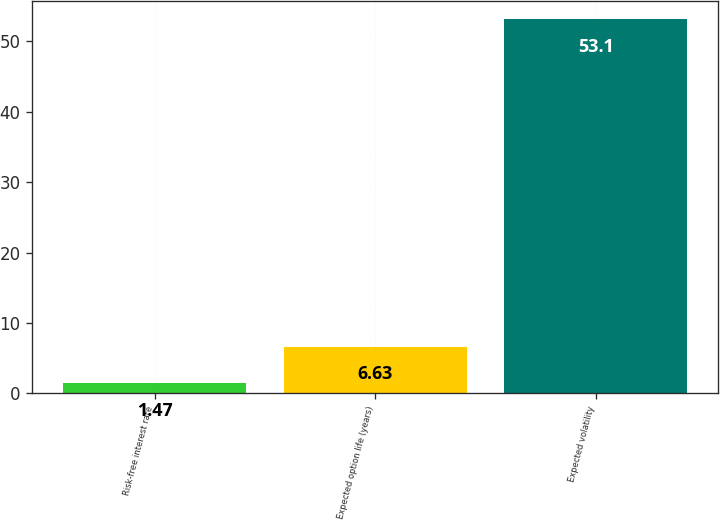<chart> <loc_0><loc_0><loc_500><loc_500><bar_chart><fcel>Risk-free interest rate<fcel>Expected option life (years)<fcel>Expected volatility<nl><fcel>1.47<fcel>6.63<fcel>53.1<nl></chart> 